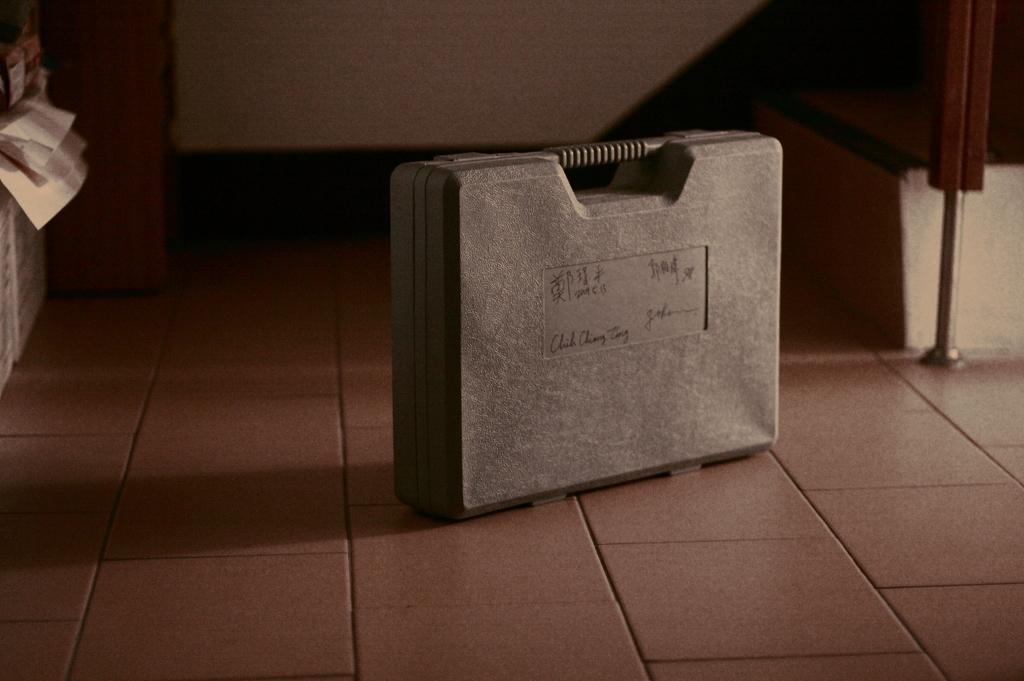Could you give a brief overview of what you see in this image? There is a suitcase on the floor. 